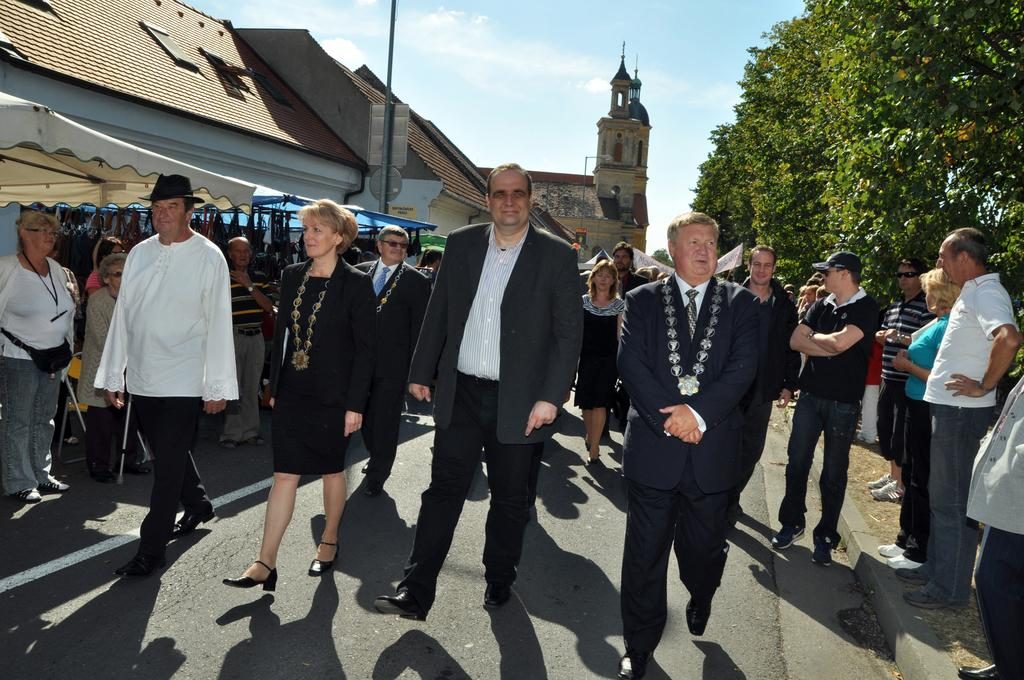How many people are in the image? There is a group of people in the image. What are some of the people doing in the image? Some people are walking, and some people are standing. What type of structures can be seen in the image? There are buildings and tents in the image. What other objects can be seen in the image? There is a pole in the image. What type of fog can be seen surrounding the carpenter in the image? There is no carpenter or fog present in the image. How does the dock appear in the image? There is no dock present in the image. 